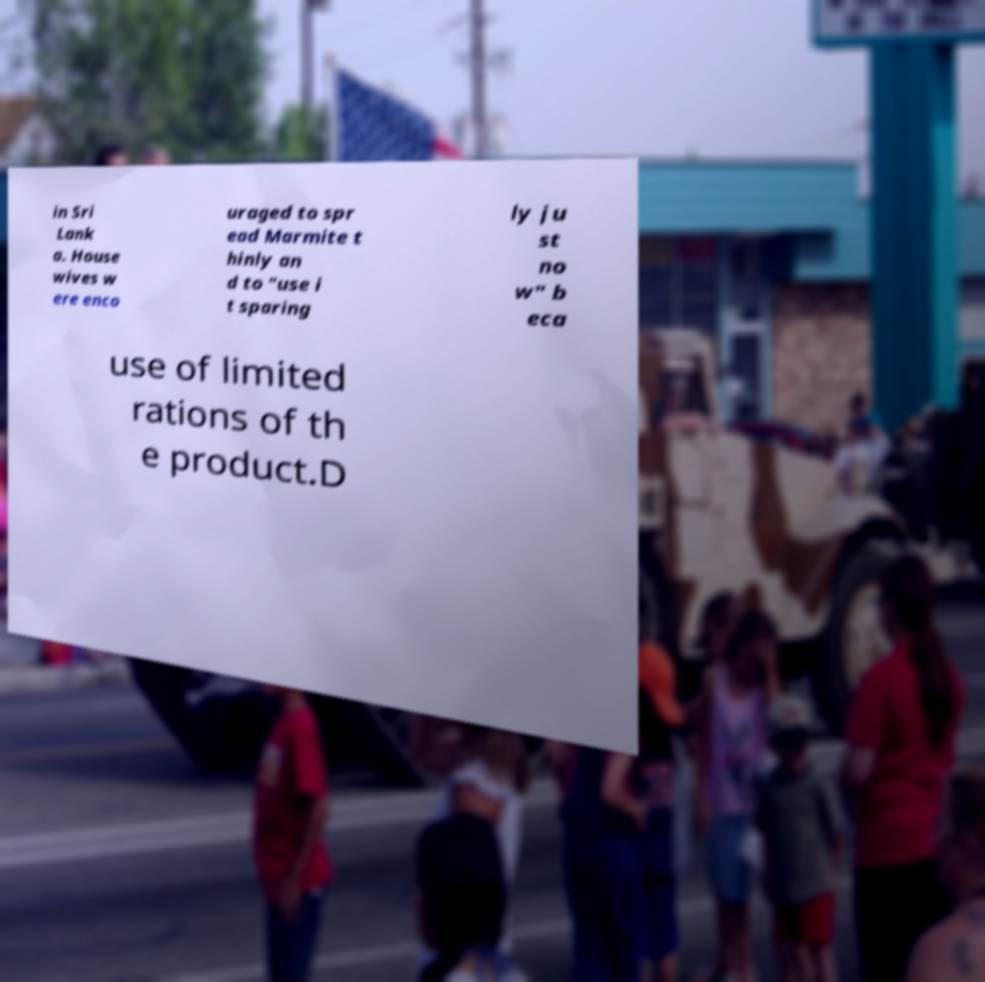Please read and relay the text visible in this image. What does it say? in Sri Lank a. House wives w ere enco uraged to spr ead Marmite t hinly an d to "use i t sparing ly ju st no w" b eca use of limited rations of th e product.D 